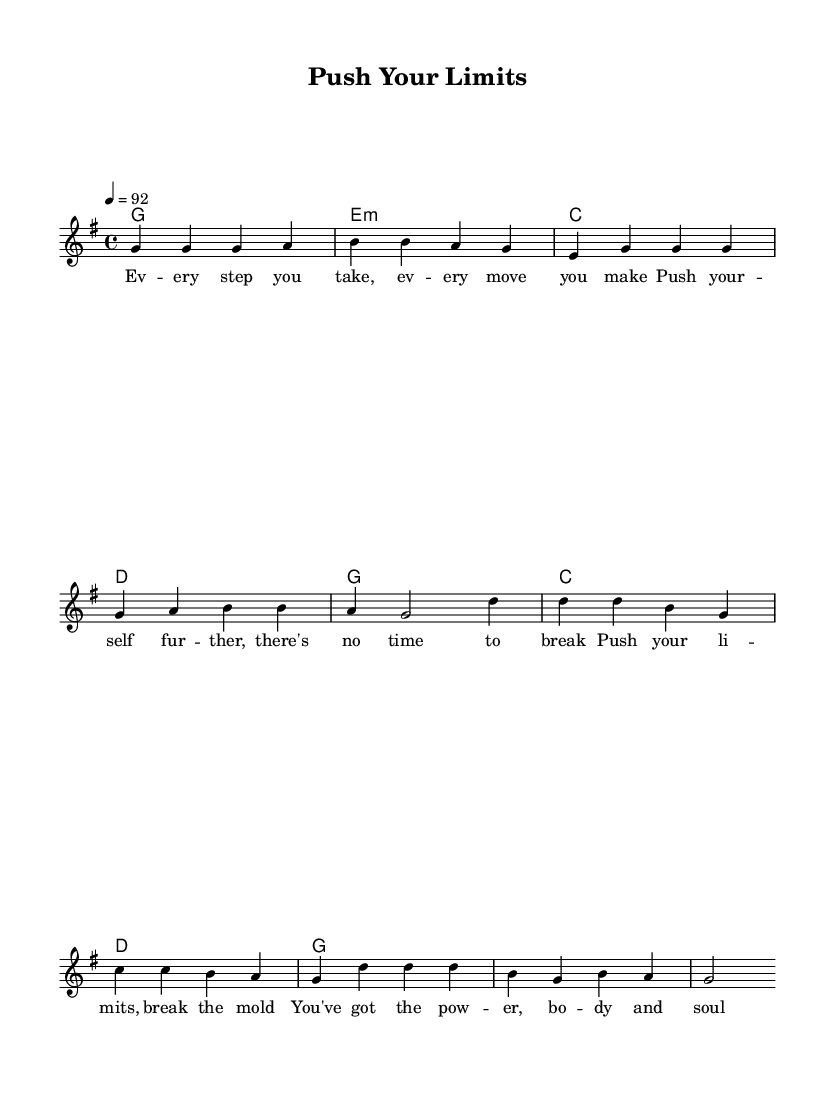What is the key signature of this music? The key signature indicates which notes are sharp or flat. In this piece, the key signature shows one sharp (F#), which is characteristic of G major.
Answer: G major What is the time signature of this music? The time signature is found at the beginning of the music, and it specifies the number of beats in each measure; here, it shows 4 beats per measure.
Answer: 4/4 What is the tempo of this music? The tempo indication tells the performer how fast to play the piece. It’s notated as 4 equals 92, meaning to play 92 quarter notes per minute.
Answer: 92 What are the lyrics of the chorus? The lyrics are directly beneath the staff. The chorus lyrics read "Push your limits, break the mold, You've got the power, body and soul."
Answer: Push your limits, break the mold, You've got the power, body and soul What chords are used in the verse? The chord names, which indicate the harmonic structure, are aligned with the verse. They show G major, E minor, C major, and D major.
Answer: G, E minor, C, D Which musical elements are typical for Reggae in this piece? Reggae often features offbeat rhythm and a laid-back feel. This piece has repetitive verses and choruses with a strong, syncopated rhythm, characteristic of Reggae music.
Answer: Strong, syncopated rhythm How many measures are in the verse? Counting the measures within the verse section will provide the answer. The verse is structured with four measures of music.
Answer: Four 